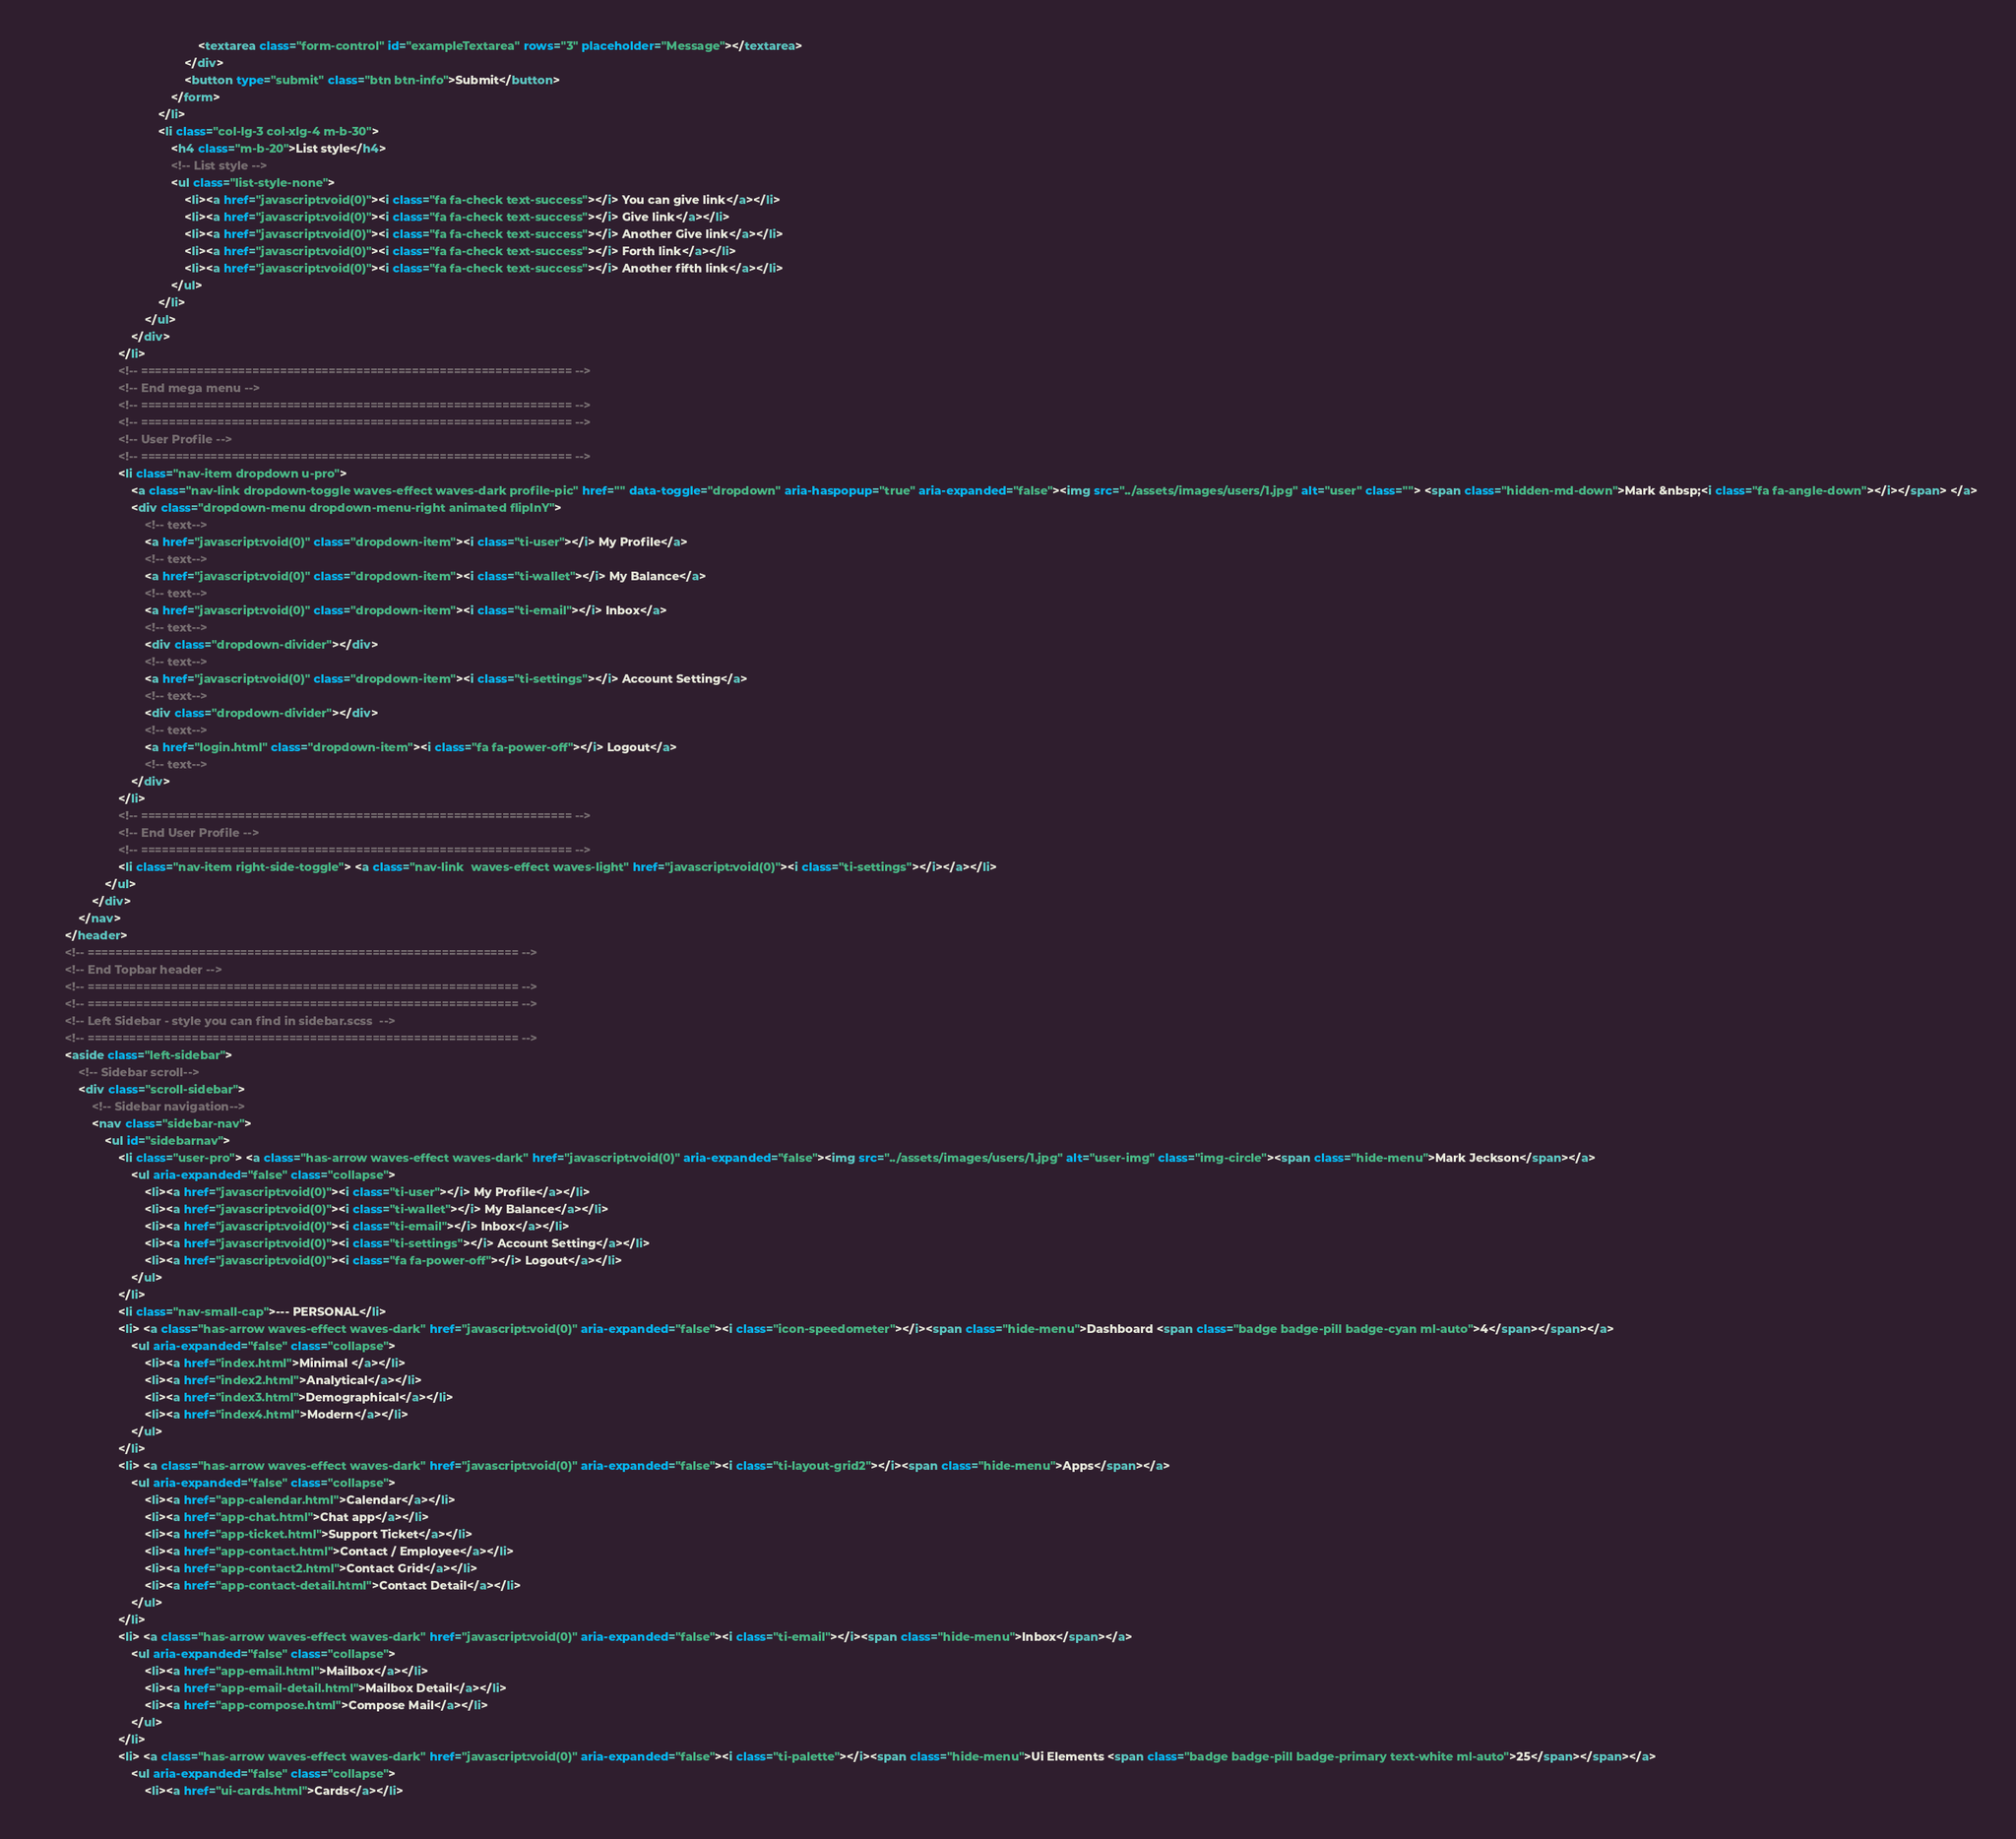Convert code to text. <code><loc_0><loc_0><loc_500><loc_500><_HTML_>                                                <textarea class="form-control" id="exampleTextarea" rows="3" placeholder="Message"></textarea>
                                            </div>
                                            <button type="submit" class="btn btn-info">Submit</button>
                                        </form>
                                    </li>
                                    <li class="col-lg-3 col-xlg-4 m-b-30">
                                        <h4 class="m-b-20">List style</h4>
                                        <!-- List style -->
                                        <ul class="list-style-none">
                                            <li><a href="javascript:void(0)"><i class="fa fa-check text-success"></i> You can give link</a></li>
                                            <li><a href="javascript:void(0)"><i class="fa fa-check text-success"></i> Give link</a></li>
                                            <li><a href="javascript:void(0)"><i class="fa fa-check text-success"></i> Another Give link</a></li>
                                            <li><a href="javascript:void(0)"><i class="fa fa-check text-success"></i> Forth link</a></li>
                                            <li><a href="javascript:void(0)"><i class="fa fa-check text-success"></i> Another fifth link</a></li>
                                        </ul>
                                    </li>
                                </ul>
                            </div>
                        </li>
                        <!-- ============================================================== -->
                        <!-- End mega menu -->
                        <!-- ============================================================== -->
                        <!-- ============================================================== -->
                        <!-- User Profile -->
                        <!-- ============================================================== -->
                        <li class="nav-item dropdown u-pro">
                            <a class="nav-link dropdown-toggle waves-effect waves-dark profile-pic" href="" data-toggle="dropdown" aria-haspopup="true" aria-expanded="false"><img src="../assets/images/users/1.jpg" alt="user" class=""> <span class="hidden-md-down">Mark &nbsp;<i class="fa fa-angle-down"></i></span> </a>
                            <div class="dropdown-menu dropdown-menu-right animated flipInY">
                                <!-- text-->
                                <a href="javascript:void(0)" class="dropdown-item"><i class="ti-user"></i> My Profile</a>
                                <!-- text-->
                                <a href="javascript:void(0)" class="dropdown-item"><i class="ti-wallet"></i> My Balance</a>
                                <!-- text-->
                                <a href="javascript:void(0)" class="dropdown-item"><i class="ti-email"></i> Inbox</a>
                                <!-- text-->
                                <div class="dropdown-divider"></div>
                                <!-- text-->
                                <a href="javascript:void(0)" class="dropdown-item"><i class="ti-settings"></i> Account Setting</a>
                                <!-- text-->
                                <div class="dropdown-divider"></div>
                                <!-- text-->
                                <a href="login.html" class="dropdown-item"><i class="fa fa-power-off"></i> Logout</a>
                                <!-- text-->
                            </div>
                        </li>
                        <!-- ============================================================== -->
                        <!-- End User Profile -->
                        <!-- ============================================================== -->
                        <li class="nav-item right-side-toggle"> <a class="nav-link  waves-effect waves-light" href="javascript:void(0)"><i class="ti-settings"></i></a></li>
                    </ul>
                </div>
            </nav>
        </header>
        <!-- ============================================================== -->
        <!-- End Topbar header -->
        <!-- ============================================================== -->
        <!-- ============================================================== -->
        <!-- Left Sidebar - style you can find in sidebar.scss  -->
        <!-- ============================================================== -->
        <aside class="left-sidebar">
            <!-- Sidebar scroll-->
            <div class="scroll-sidebar">
                <!-- Sidebar navigation-->
                <nav class="sidebar-nav">
                    <ul id="sidebarnav">
                        <li class="user-pro"> <a class="has-arrow waves-effect waves-dark" href="javascript:void(0)" aria-expanded="false"><img src="../assets/images/users/1.jpg" alt="user-img" class="img-circle"><span class="hide-menu">Mark Jeckson</span></a>
                            <ul aria-expanded="false" class="collapse">
                                <li><a href="javascript:void(0)"><i class="ti-user"></i> My Profile</a></li>
                                <li><a href="javascript:void(0)"><i class="ti-wallet"></i> My Balance</a></li>
                                <li><a href="javascript:void(0)"><i class="ti-email"></i> Inbox</a></li>
                                <li><a href="javascript:void(0)"><i class="ti-settings"></i> Account Setting</a></li>
                                <li><a href="javascript:void(0)"><i class="fa fa-power-off"></i> Logout</a></li>
                            </ul>
                        </li>
                        <li class="nav-small-cap">--- PERSONAL</li>
                        <li> <a class="has-arrow waves-effect waves-dark" href="javascript:void(0)" aria-expanded="false"><i class="icon-speedometer"></i><span class="hide-menu">Dashboard <span class="badge badge-pill badge-cyan ml-auto">4</span></span></a>
                            <ul aria-expanded="false" class="collapse">
                                <li><a href="index.html">Minimal </a></li>
                                <li><a href="index2.html">Analytical</a></li>
                                <li><a href="index3.html">Demographical</a></li>
                                <li><a href="index4.html">Modern</a></li>
                            </ul>
                        </li>
                        <li> <a class="has-arrow waves-effect waves-dark" href="javascript:void(0)" aria-expanded="false"><i class="ti-layout-grid2"></i><span class="hide-menu">Apps</span></a>
                            <ul aria-expanded="false" class="collapse">
                                <li><a href="app-calendar.html">Calendar</a></li>
                                <li><a href="app-chat.html">Chat app</a></li>
                                <li><a href="app-ticket.html">Support Ticket</a></li>
                                <li><a href="app-contact.html">Contact / Employee</a></li>
                                <li><a href="app-contact2.html">Contact Grid</a></li>
                                <li><a href="app-contact-detail.html">Contact Detail</a></li>
                            </ul>
                        </li>
                        <li> <a class="has-arrow waves-effect waves-dark" href="javascript:void(0)" aria-expanded="false"><i class="ti-email"></i><span class="hide-menu">Inbox</span></a>
                            <ul aria-expanded="false" class="collapse">
                                <li><a href="app-email.html">Mailbox</a></li>
                                <li><a href="app-email-detail.html">Mailbox Detail</a></li>
                                <li><a href="app-compose.html">Compose Mail</a></li>
                            </ul>
                        </li>
                        <li> <a class="has-arrow waves-effect waves-dark" href="javascript:void(0)" aria-expanded="false"><i class="ti-palette"></i><span class="hide-menu">Ui Elements <span class="badge badge-pill badge-primary text-white ml-auto">25</span></span></a>
                            <ul aria-expanded="false" class="collapse">
                                <li><a href="ui-cards.html">Cards</a></li></code> 